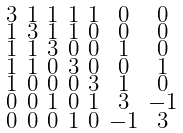<formula> <loc_0><loc_0><loc_500><loc_500>\begin{smallmatrix} 3 & 1 & 1 & 1 & 1 & 0 & 0 \\ 1 & 3 & 1 & 1 & 0 & 0 & 0 \\ 1 & 1 & 3 & 0 & 0 & 1 & 0 \\ 1 & 1 & 0 & 3 & 0 & 0 & 1 \\ 1 & 0 & 0 & 0 & 3 & 1 & 0 \\ 0 & 0 & 1 & 0 & 1 & 3 & - 1 \\ 0 & 0 & 0 & 1 & 0 & - 1 & 3 \end{smallmatrix}</formula> 